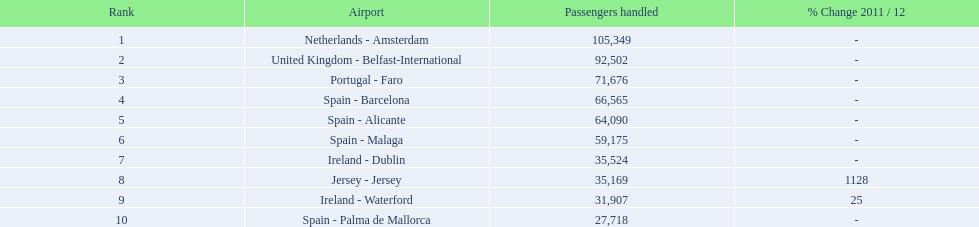What is the maximum number of passengers managed? 105,349. What is the destination for passengers departing from the location serving 105,349 travelers? Netherlands - Amsterdam. 